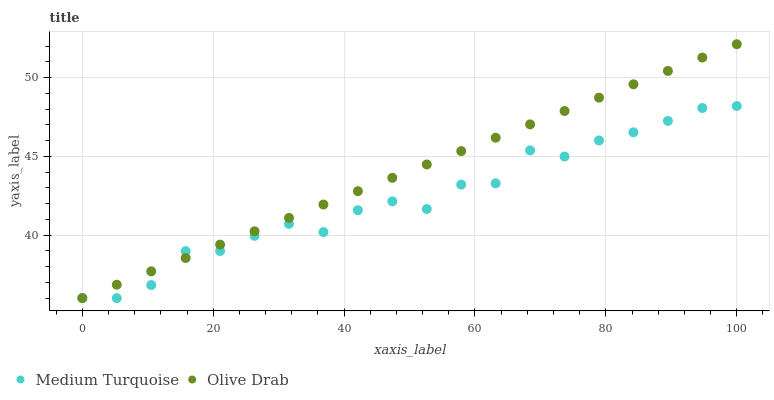Does Medium Turquoise have the minimum area under the curve?
Answer yes or no. Yes. Does Olive Drab have the maximum area under the curve?
Answer yes or no. Yes. Does Medium Turquoise have the maximum area under the curve?
Answer yes or no. No. Is Olive Drab the smoothest?
Answer yes or no. Yes. Is Medium Turquoise the roughest?
Answer yes or no. Yes. Is Medium Turquoise the smoothest?
Answer yes or no. No. Does Olive Drab have the lowest value?
Answer yes or no. Yes. Does Olive Drab have the highest value?
Answer yes or no. Yes. Does Medium Turquoise have the highest value?
Answer yes or no. No. Does Medium Turquoise intersect Olive Drab?
Answer yes or no. Yes. Is Medium Turquoise less than Olive Drab?
Answer yes or no. No. Is Medium Turquoise greater than Olive Drab?
Answer yes or no. No. 